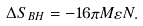<formula> <loc_0><loc_0><loc_500><loc_500>\Delta S _ { B H } = - 1 6 \pi M \varepsilon N .</formula> 